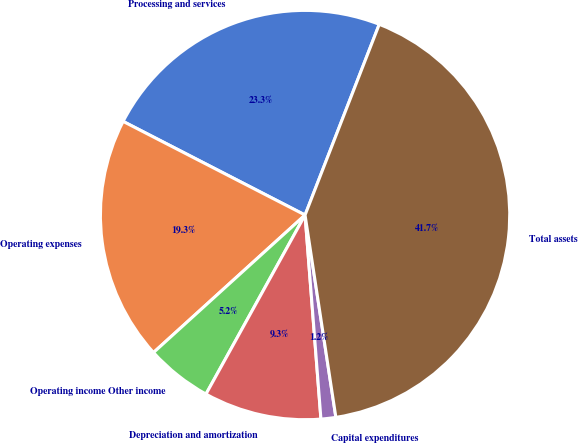Convert chart. <chart><loc_0><loc_0><loc_500><loc_500><pie_chart><fcel>Processing and services<fcel>Operating expenses<fcel>Operating income Other income<fcel>Depreciation and amortization<fcel>Capital expenditures<fcel>Total assets<nl><fcel>23.34%<fcel>19.29%<fcel>5.23%<fcel>9.28%<fcel>1.17%<fcel>41.69%<nl></chart> 